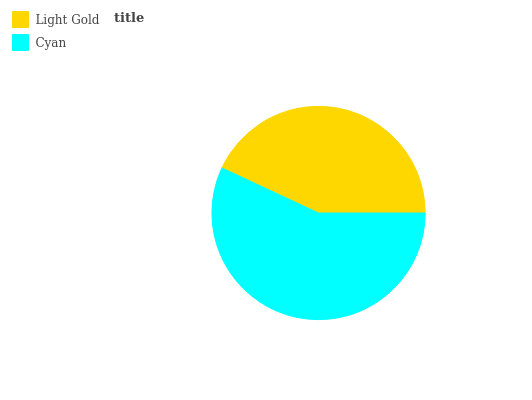Is Light Gold the minimum?
Answer yes or no. Yes. Is Cyan the maximum?
Answer yes or no. Yes. Is Cyan the minimum?
Answer yes or no. No. Is Cyan greater than Light Gold?
Answer yes or no. Yes. Is Light Gold less than Cyan?
Answer yes or no. Yes. Is Light Gold greater than Cyan?
Answer yes or no. No. Is Cyan less than Light Gold?
Answer yes or no. No. Is Cyan the high median?
Answer yes or no. Yes. Is Light Gold the low median?
Answer yes or no. Yes. Is Light Gold the high median?
Answer yes or no. No. Is Cyan the low median?
Answer yes or no. No. 